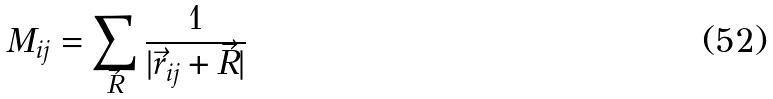<formula> <loc_0><loc_0><loc_500><loc_500>M _ { i j } = \sum _ { \vec { R } } \frac { 1 } { | \vec { r } _ { i j } + \vec { R } | }</formula> 